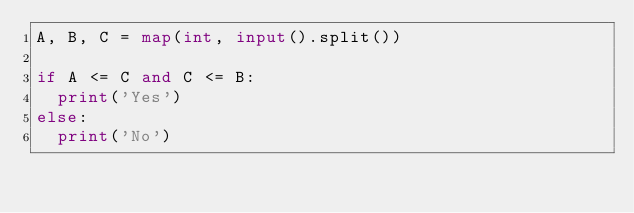Convert code to text. <code><loc_0><loc_0><loc_500><loc_500><_Python_>A, B, C = map(int, input().split())

if A <= C and C <= B:
  print('Yes')
else:
  print('No')</code> 